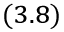<formula> <loc_0><loc_0><loc_500><loc_500>_ { ( 3 . 8 ) }</formula> 